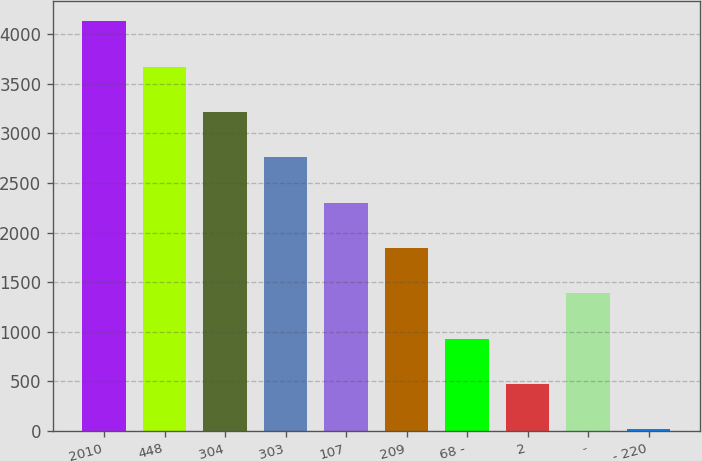Convert chart to OTSL. <chart><loc_0><loc_0><loc_500><loc_500><bar_chart><fcel>2010<fcel>448<fcel>304<fcel>303<fcel>107<fcel>209<fcel>68 -<fcel>2<fcel>-<fcel>- 220<nl><fcel>4133.4<fcel>3675.8<fcel>3218.2<fcel>2760.6<fcel>2303<fcel>1845.4<fcel>930.2<fcel>472.6<fcel>1387.8<fcel>15<nl></chart> 